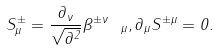<formula> <loc_0><loc_0><loc_500><loc_500>S ^ { \pm } _ { \mu } = \frac { \partial _ { \nu } } { \sqrt { \partial ^ { 2 } } } \beta ^ { \pm \nu } \ _ { \mu } , \partial _ { \mu } S ^ { \pm \mu } = 0 .</formula> 